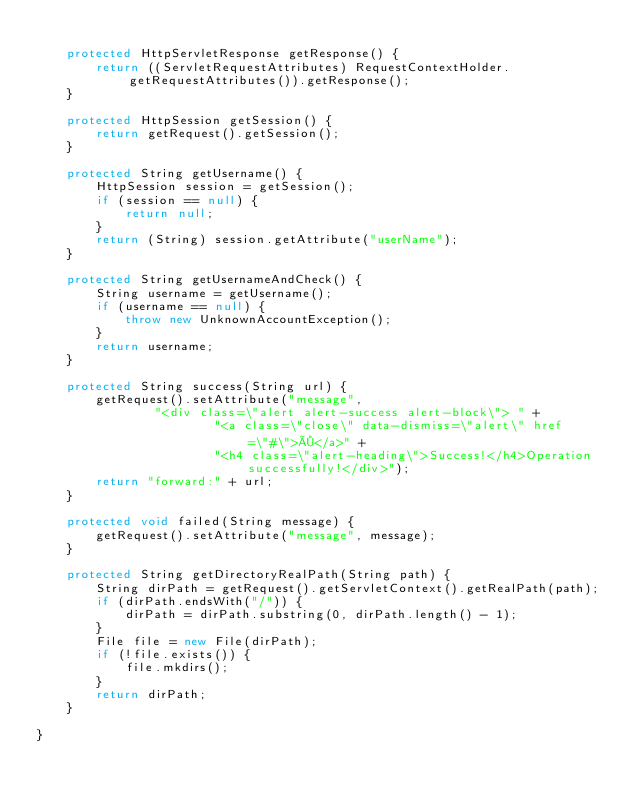Convert code to text. <code><loc_0><loc_0><loc_500><loc_500><_Java_>
    protected HttpServletResponse getResponse() {
        return ((ServletRequestAttributes) RequestContextHolder.getRequestAttributes()).getResponse();
    }

    protected HttpSession getSession() {
        return getRequest().getSession();
    }

    protected String getUsername() {
        HttpSession session = getSession();
        if (session == null) {
            return null;
        }
        return (String) session.getAttribute("userName");
    }

    protected String getUsernameAndCheck() {
        String username = getUsername();
        if (username == null) {
            throw new UnknownAccountException();
        }
        return username;
    }

    protected String success(String url) {
        getRequest().setAttribute("message",
                "<div class=\"alert alert-success alert-block\"> " +
                        "<a class=\"close\" data-dismiss=\"alert\" href=\"#\">×</a>" +
                        "<h4 class=\"alert-heading\">Success!</h4>Operation successfully!</div>");
        return "forward:" + url;
    }

    protected void failed(String message) {
        getRequest().setAttribute("message", message);
    }

    protected String getDirectoryRealPath(String path) {
        String dirPath = getRequest().getServletContext().getRealPath(path);
        if (dirPath.endsWith("/")) {
            dirPath = dirPath.substring(0, dirPath.length() - 1);
        }
        File file = new File(dirPath);
        if (!file.exists()) {
            file.mkdirs();
        }
        return dirPath;
    }

}
</code> 